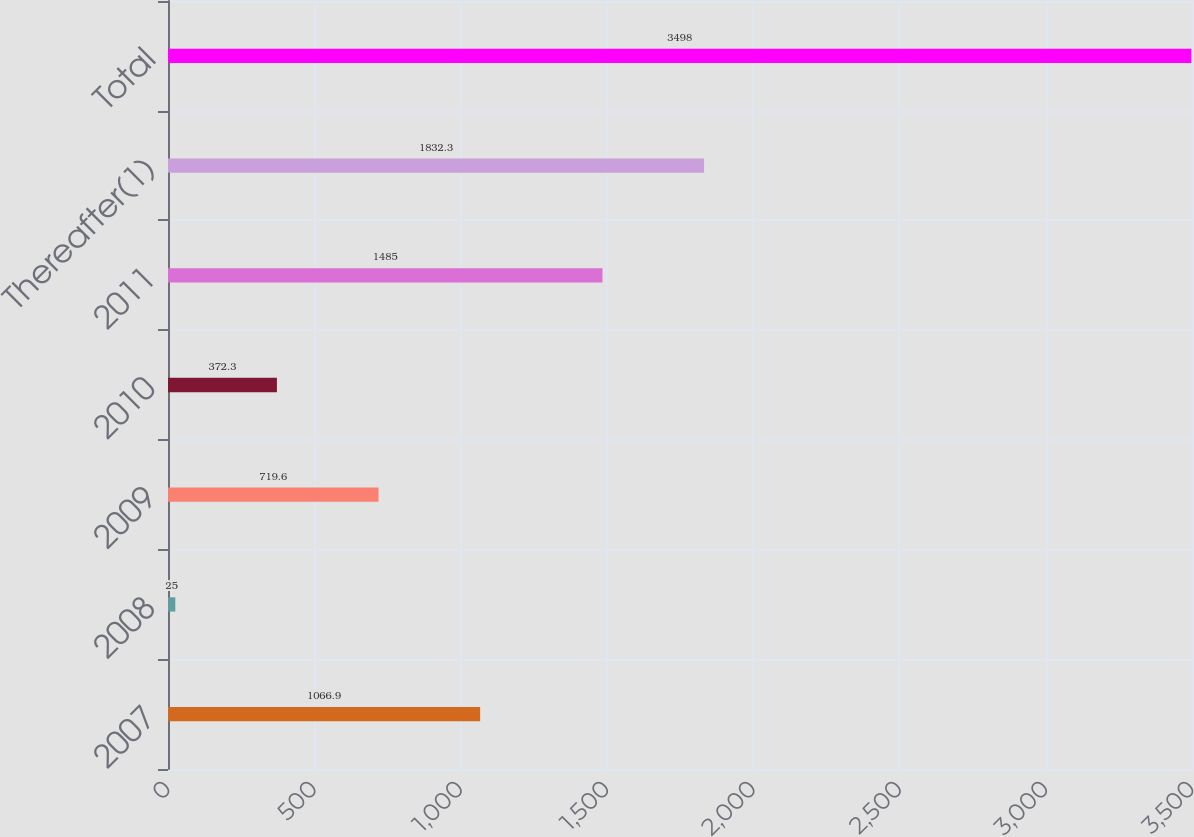<chart> <loc_0><loc_0><loc_500><loc_500><bar_chart><fcel>2007<fcel>2008<fcel>2009<fcel>2010<fcel>2011<fcel>Thereafter(1)<fcel>Total<nl><fcel>1066.9<fcel>25<fcel>719.6<fcel>372.3<fcel>1485<fcel>1832.3<fcel>3498<nl></chart> 